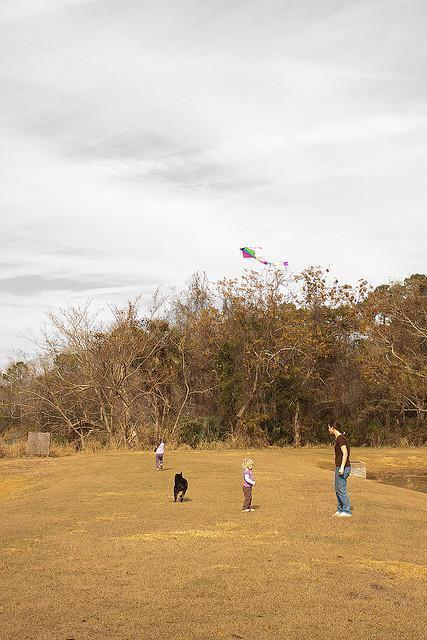What breed dog it is?
Pick the correct solution from the four options below to address the question.
Options: Poodle, pug, dachshund, cane corso. Cane corso. 